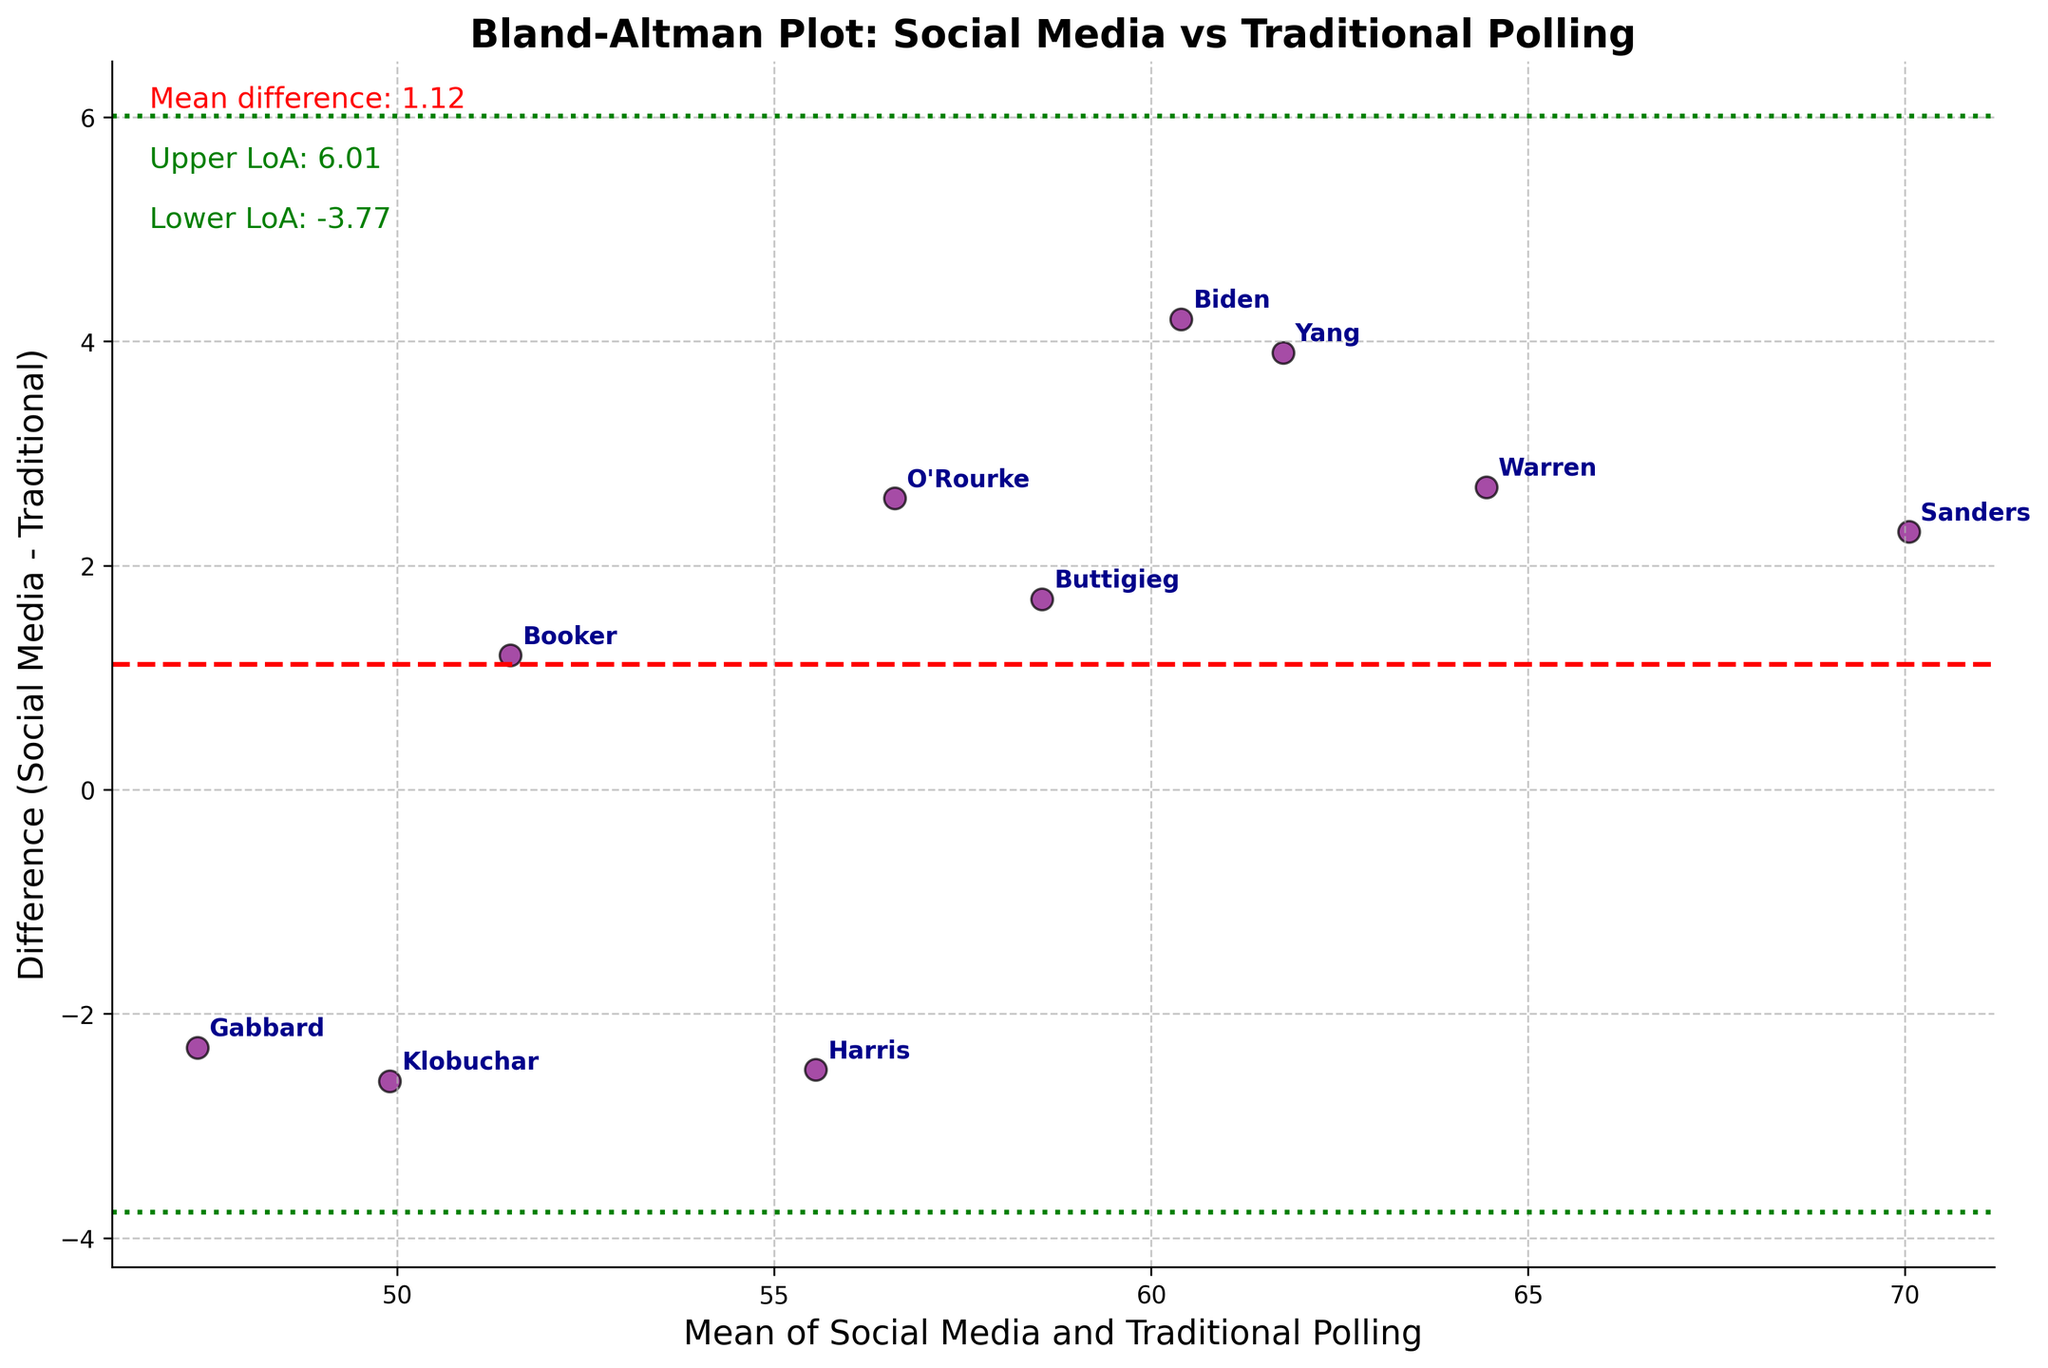what is the title of the figure? The title is given at the top of the plot, indicating the overall topic it addresses.
Answer: Bland-Altman Plot: Social Media vs Traditional Polling How many data points are plotted in the figure? Count each data point (scatter point) on the plot, each of which represents a candidate.
Answer: 10 What is the color of the scatter points? Observe the scatter points in the plot to determine their color.
Answer: Purple Which candidate has the highest difference between Social Media Sentiment and Traditional Polling? Look at the vertical distances of the points from the zero line to find the maximum difference.
Answer: Sanders What is the mean difference between Social Media sentiment and Traditional Polling? This value is indicated by the red dashed line on the plot and possibly annotated.
Answer: Approximately 1.51 What are the upper and lower limits of agreement (LoA)? These limits are shown with green lines, and the exact values are annotated on the plot.
Answer: Upper LoA: ~7.78, Lower LoA: ~-4.76 How are the differences between the methods distributed in relation to the mean difference? Compare the scatter of the points around the red mean difference line to understand the spread.
Answer: Points are scattered around the red line, showing variability Which candidates are within the limits of agreement? Identify points that are within the upper and lower green lines.
Answer: All candidates Is there a visible trend linking the means of the methods to the differences? Look at the general direction of the scatter points relative to their mean values.
Answer: No clear trend Who has a social media sentiment that significantly deviates from traditional polling methods? Look for points with the largest differences (upwards or downwards) from the red line.
Answer: Sanders 